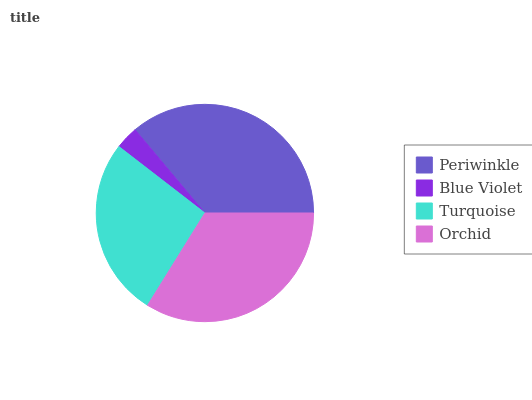Is Blue Violet the minimum?
Answer yes or no. Yes. Is Periwinkle the maximum?
Answer yes or no. Yes. Is Turquoise the minimum?
Answer yes or no. No. Is Turquoise the maximum?
Answer yes or no. No. Is Turquoise greater than Blue Violet?
Answer yes or no. Yes. Is Blue Violet less than Turquoise?
Answer yes or no. Yes. Is Blue Violet greater than Turquoise?
Answer yes or no. No. Is Turquoise less than Blue Violet?
Answer yes or no. No. Is Orchid the high median?
Answer yes or no. Yes. Is Turquoise the low median?
Answer yes or no. Yes. Is Periwinkle the high median?
Answer yes or no. No. Is Blue Violet the low median?
Answer yes or no. No. 